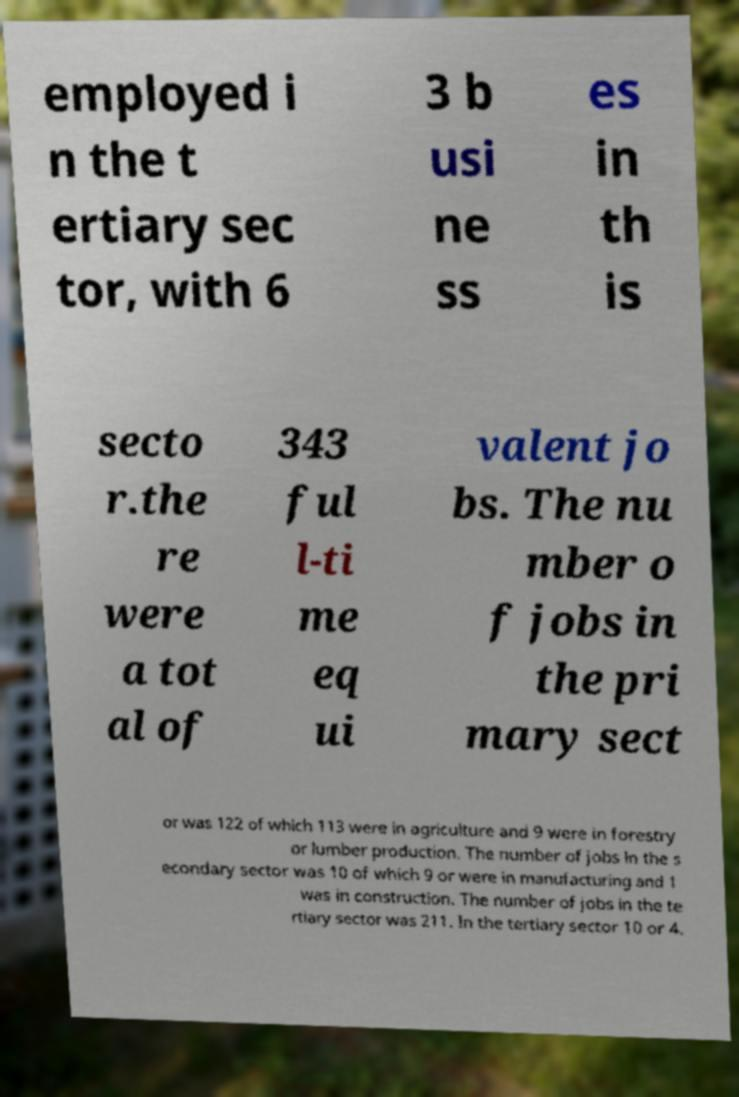I need the written content from this picture converted into text. Can you do that? employed i n the t ertiary sec tor, with 6 3 b usi ne ss es in th is secto r.the re were a tot al of 343 ful l-ti me eq ui valent jo bs. The nu mber o f jobs in the pri mary sect or was 122 of which 113 were in agriculture and 9 were in forestry or lumber production. The number of jobs in the s econdary sector was 10 of which 9 or were in manufacturing and 1 was in construction. The number of jobs in the te rtiary sector was 211. In the tertiary sector 10 or 4. 